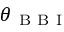Convert formula to latex. <formula><loc_0><loc_0><loc_500><loc_500>\theta _ { B B I }</formula> 